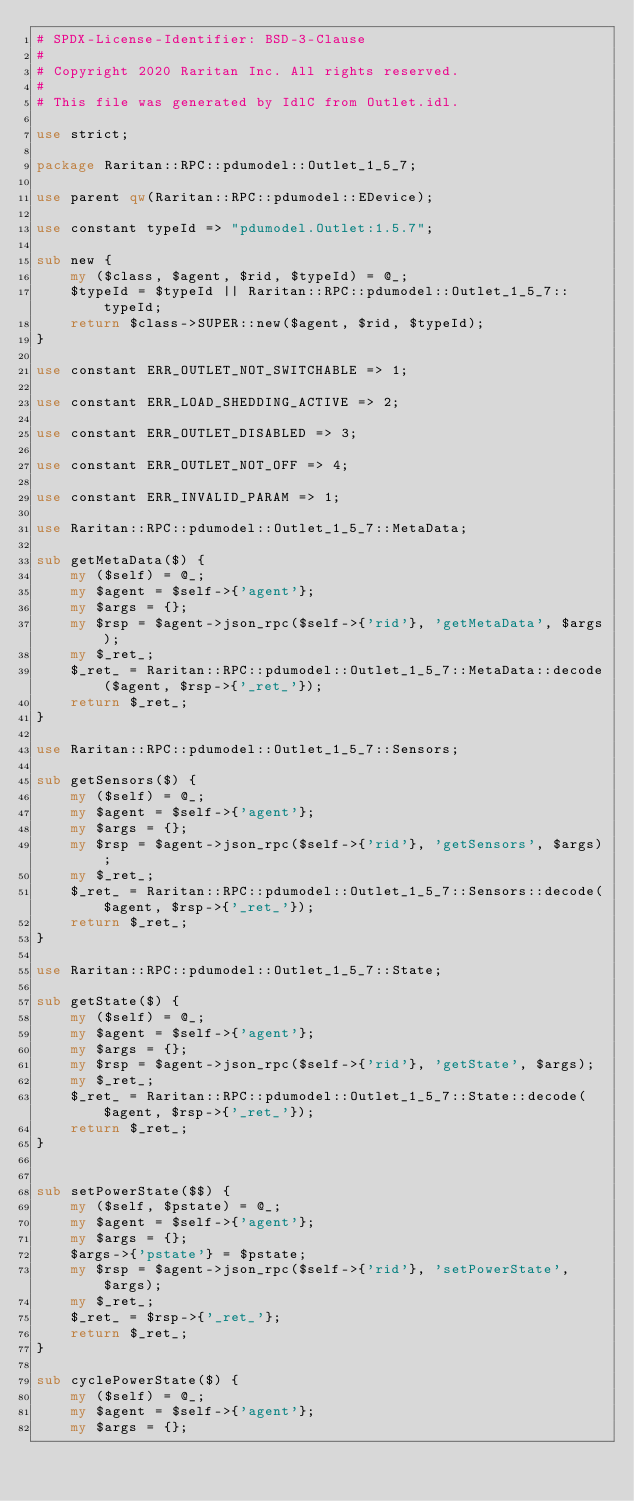Convert code to text. <code><loc_0><loc_0><loc_500><loc_500><_Perl_># SPDX-License-Identifier: BSD-3-Clause
#
# Copyright 2020 Raritan Inc. All rights reserved.
#
# This file was generated by IdlC from Outlet.idl.

use strict;

package Raritan::RPC::pdumodel::Outlet_1_5_7;

use parent qw(Raritan::RPC::pdumodel::EDevice);

use constant typeId => "pdumodel.Outlet:1.5.7";

sub new {
    my ($class, $agent, $rid, $typeId) = @_;
    $typeId = $typeId || Raritan::RPC::pdumodel::Outlet_1_5_7::typeId;
    return $class->SUPER::new($agent, $rid, $typeId);
}

use constant ERR_OUTLET_NOT_SWITCHABLE => 1;

use constant ERR_LOAD_SHEDDING_ACTIVE => 2;

use constant ERR_OUTLET_DISABLED => 3;

use constant ERR_OUTLET_NOT_OFF => 4;

use constant ERR_INVALID_PARAM => 1;

use Raritan::RPC::pdumodel::Outlet_1_5_7::MetaData;

sub getMetaData($) {
    my ($self) = @_;
    my $agent = $self->{'agent'};
    my $args = {};
    my $rsp = $agent->json_rpc($self->{'rid'}, 'getMetaData', $args);
    my $_ret_;
    $_ret_ = Raritan::RPC::pdumodel::Outlet_1_5_7::MetaData::decode($agent, $rsp->{'_ret_'});
    return $_ret_;
}

use Raritan::RPC::pdumodel::Outlet_1_5_7::Sensors;

sub getSensors($) {
    my ($self) = @_;
    my $agent = $self->{'agent'};
    my $args = {};
    my $rsp = $agent->json_rpc($self->{'rid'}, 'getSensors', $args);
    my $_ret_;
    $_ret_ = Raritan::RPC::pdumodel::Outlet_1_5_7::Sensors::decode($agent, $rsp->{'_ret_'});
    return $_ret_;
}

use Raritan::RPC::pdumodel::Outlet_1_5_7::State;

sub getState($) {
    my ($self) = @_;
    my $agent = $self->{'agent'};
    my $args = {};
    my $rsp = $agent->json_rpc($self->{'rid'}, 'getState', $args);
    my $_ret_;
    $_ret_ = Raritan::RPC::pdumodel::Outlet_1_5_7::State::decode($agent, $rsp->{'_ret_'});
    return $_ret_;
}


sub setPowerState($$) {
    my ($self, $pstate) = @_;
    my $agent = $self->{'agent'};
    my $args = {};
    $args->{'pstate'} = $pstate;
    my $rsp = $agent->json_rpc($self->{'rid'}, 'setPowerState', $args);
    my $_ret_;
    $_ret_ = $rsp->{'_ret_'};
    return $_ret_;
}

sub cyclePowerState($) {
    my ($self) = @_;
    my $agent = $self->{'agent'};
    my $args = {};</code> 